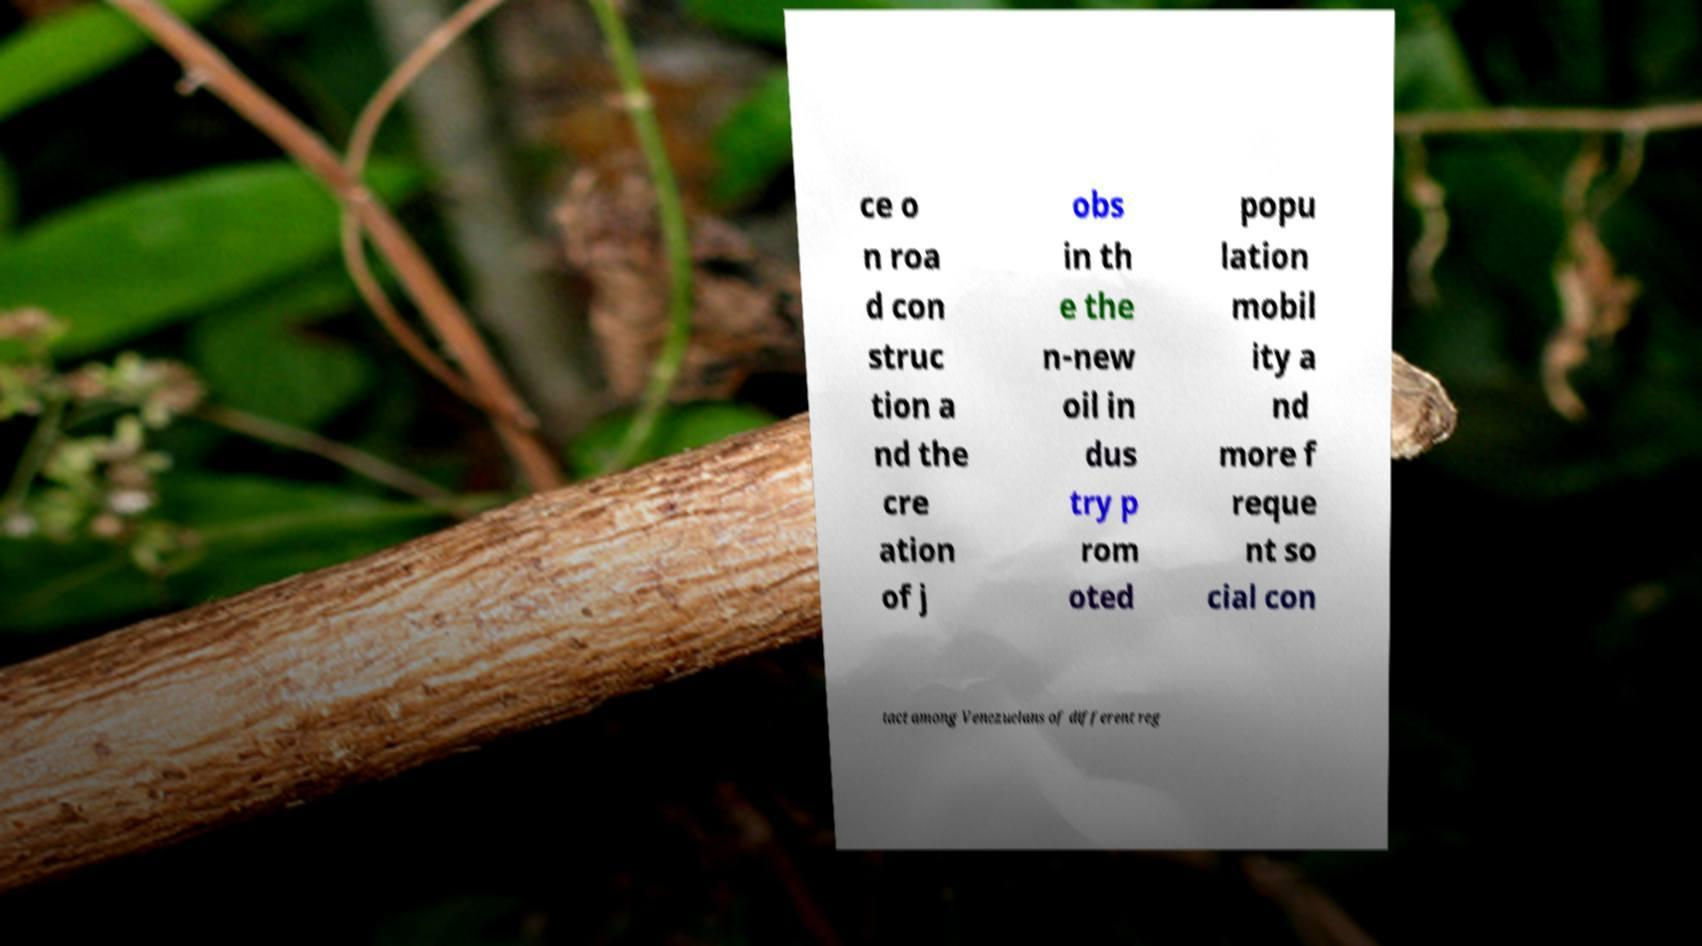What messages or text are displayed in this image? I need them in a readable, typed format. ce o n roa d con struc tion a nd the cre ation of j obs in th e the n-new oil in dus try p rom oted popu lation mobil ity a nd more f reque nt so cial con tact among Venezuelans of different reg 